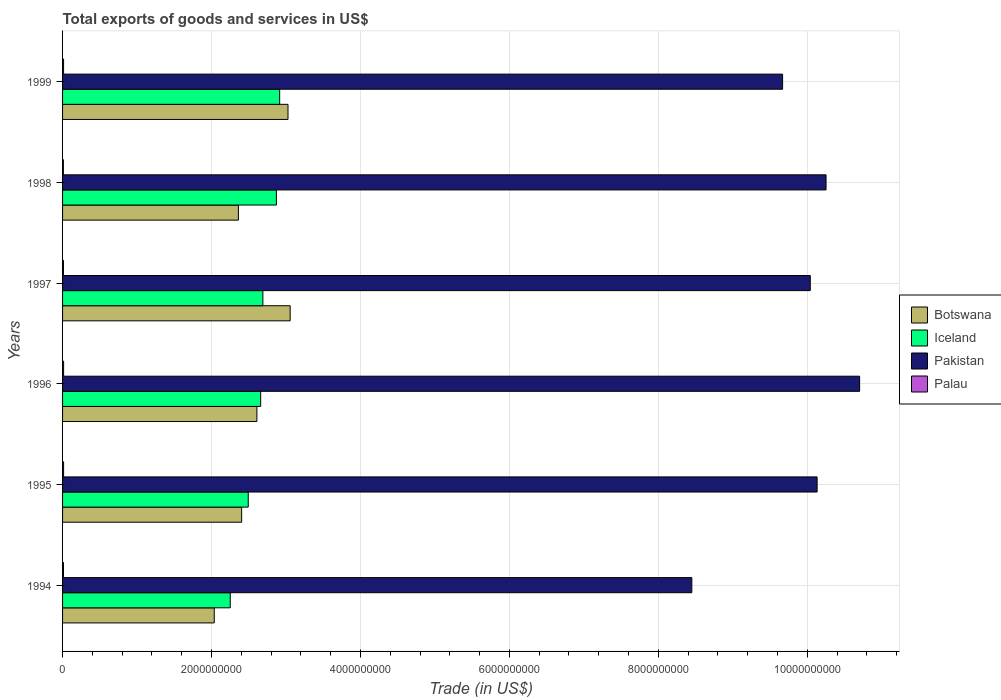Are the number of bars on each tick of the Y-axis equal?
Provide a short and direct response. Yes. In how many cases, is the number of bars for a given year not equal to the number of legend labels?
Keep it short and to the point. 0. What is the total exports of goods and services in Palau in 1997?
Offer a terse response. 1.18e+07. Across all years, what is the maximum total exports of goods and services in Palau?
Provide a succinct answer. 1.39e+07. Across all years, what is the minimum total exports of goods and services in Pakistan?
Keep it short and to the point. 8.45e+09. In which year was the total exports of goods and services in Palau maximum?
Ensure brevity in your answer.  1996. In which year was the total exports of goods and services in Pakistan minimum?
Provide a short and direct response. 1994. What is the total total exports of goods and services in Palau in the graph?
Keep it short and to the point. 7.69e+07. What is the difference between the total exports of goods and services in Iceland in 1998 and that in 1999?
Your answer should be very brief. -4.36e+07. What is the difference between the total exports of goods and services in Iceland in 1997 and the total exports of goods and services in Pakistan in 1998?
Make the answer very short. -7.56e+09. What is the average total exports of goods and services in Palau per year?
Provide a succinct answer. 1.28e+07. In the year 1994, what is the difference between the total exports of goods and services in Palau and total exports of goods and services in Iceland?
Your response must be concise. -2.24e+09. What is the ratio of the total exports of goods and services in Pakistan in 1996 to that in 1997?
Provide a short and direct response. 1.07. Is the total exports of goods and services in Botswana in 1995 less than that in 1998?
Ensure brevity in your answer.  No. Is the difference between the total exports of goods and services in Palau in 1995 and 1999 greater than the difference between the total exports of goods and services in Iceland in 1995 and 1999?
Keep it short and to the point. Yes. What is the difference between the highest and the second highest total exports of goods and services in Botswana?
Make the answer very short. 2.92e+07. What is the difference between the highest and the lowest total exports of goods and services in Botswana?
Your answer should be very brief. 1.02e+09. In how many years, is the total exports of goods and services in Iceland greater than the average total exports of goods and services in Iceland taken over all years?
Offer a very short reply. 4. Is the sum of the total exports of goods and services in Iceland in 1994 and 1996 greater than the maximum total exports of goods and services in Palau across all years?
Your response must be concise. Yes. What does the 1st bar from the top in 1999 represents?
Give a very brief answer. Palau. What does the 2nd bar from the bottom in 1996 represents?
Your response must be concise. Iceland. Is it the case that in every year, the sum of the total exports of goods and services in Palau and total exports of goods and services in Botswana is greater than the total exports of goods and services in Iceland?
Provide a short and direct response. No. Are all the bars in the graph horizontal?
Keep it short and to the point. Yes. How many years are there in the graph?
Your answer should be very brief. 6. What is the difference between two consecutive major ticks on the X-axis?
Provide a short and direct response. 2.00e+09. Are the values on the major ticks of X-axis written in scientific E-notation?
Your answer should be compact. No. Does the graph contain any zero values?
Ensure brevity in your answer.  No. What is the title of the graph?
Your answer should be compact. Total exports of goods and services in US$. What is the label or title of the X-axis?
Ensure brevity in your answer.  Trade (in US$). What is the label or title of the Y-axis?
Provide a short and direct response. Years. What is the Trade (in US$) of Botswana in 1994?
Make the answer very short. 2.04e+09. What is the Trade (in US$) in Iceland in 1994?
Give a very brief answer. 2.25e+09. What is the Trade (in US$) in Pakistan in 1994?
Provide a succinct answer. 8.45e+09. What is the Trade (in US$) in Palau in 1994?
Your response must be concise. 1.26e+07. What is the Trade (in US$) in Botswana in 1995?
Offer a terse response. 2.40e+09. What is the Trade (in US$) in Iceland in 1995?
Your answer should be very brief. 2.49e+09. What is the Trade (in US$) in Pakistan in 1995?
Offer a very short reply. 1.01e+1. What is the Trade (in US$) of Palau in 1995?
Offer a very short reply. 1.39e+07. What is the Trade (in US$) in Botswana in 1996?
Make the answer very short. 2.61e+09. What is the Trade (in US$) in Iceland in 1996?
Give a very brief answer. 2.66e+09. What is the Trade (in US$) of Pakistan in 1996?
Keep it short and to the point. 1.07e+1. What is the Trade (in US$) of Palau in 1996?
Offer a very short reply. 1.39e+07. What is the Trade (in US$) in Botswana in 1997?
Keep it short and to the point. 3.06e+09. What is the Trade (in US$) of Iceland in 1997?
Make the answer very short. 2.69e+09. What is the Trade (in US$) in Pakistan in 1997?
Offer a very short reply. 1.00e+1. What is the Trade (in US$) in Palau in 1997?
Your answer should be very brief. 1.18e+07. What is the Trade (in US$) of Botswana in 1998?
Your answer should be very brief. 2.36e+09. What is the Trade (in US$) of Iceland in 1998?
Offer a very short reply. 2.87e+09. What is the Trade (in US$) of Pakistan in 1998?
Your answer should be compact. 1.03e+1. What is the Trade (in US$) of Palau in 1998?
Provide a short and direct response. 1.11e+07. What is the Trade (in US$) of Botswana in 1999?
Keep it short and to the point. 3.03e+09. What is the Trade (in US$) of Iceland in 1999?
Your response must be concise. 2.92e+09. What is the Trade (in US$) of Pakistan in 1999?
Offer a very short reply. 9.67e+09. What is the Trade (in US$) of Palau in 1999?
Offer a terse response. 1.36e+07. Across all years, what is the maximum Trade (in US$) of Botswana?
Give a very brief answer. 3.06e+09. Across all years, what is the maximum Trade (in US$) in Iceland?
Provide a succinct answer. 2.92e+09. Across all years, what is the maximum Trade (in US$) of Pakistan?
Provide a short and direct response. 1.07e+1. Across all years, what is the maximum Trade (in US$) in Palau?
Offer a terse response. 1.39e+07. Across all years, what is the minimum Trade (in US$) in Botswana?
Offer a very short reply. 2.04e+09. Across all years, what is the minimum Trade (in US$) in Iceland?
Offer a very short reply. 2.25e+09. Across all years, what is the minimum Trade (in US$) of Pakistan?
Your answer should be compact. 8.45e+09. Across all years, what is the minimum Trade (in US$) in Palau?
Your answer should be compact. 1.11e+07. What is the total Trade (in US$) of Botswana in the graph?
Ensure brevity in your answer.  1.55e+1. What is the total Trade (in US$) in Iceland in the graph?
Ensure brevity in your answer.  1.59e+1. What is the total Trade (in US$) of Pakistan in the graph?
Your answer should be very brief. 5.92e+1. What is the total Trade (in US$) of Palau in the graph?
Provide a succinct answer. 7.69e+07. What is the difference between the Trade (in US$) in Botswana in 1994 and that in 1995?
Provide a short and direct response. -3.68e+08. What is the difference between the Trade (in US$) of Iceland in 1994 and that in 1995?
Offer a terse response. -2.42e+08. What is the difference between the Trade (in US$) of Pakistan in 1994 and that in 1995?
Your response must be concise. -1.68e+09. What is the difference between the Trade (in US$) in Palau in 1994 and that in 1995?
Provide a short and direct response. -1.27e+06. What is the difference between the Trade (in US$) in Botswana in 1994 and that in 1996?
Provide a succinct answer. -5.73e+08. What is the difference between the Trade (in US$) in Iceland in 1994 and that in 1996?
Ensure brevity in your answer.  -4.08e+08. What is the difference between the Trade (in US$) of Pakistan in 1994 and that in 1996?
Your answer should be compact. -2.25e+09. What is the difference between the Trade (in US$) of Palau in 1994 and that in 1996?
Keep it short and to the point. -1.31e+06. What is the difference between the Trade (in US$) of Botswana in 1994 and that in 1997?
Provide a short and direct response. -1.02e+09. What is the difference between the Trade (in US$) of Iceland in 1994 and that in 1997?
Ensure brevity in your answer.  -4.38e+08. What is the difference between the Trade (in US$) of Pakistan in 1994 and that in 1997?
Offer a very short reply. -1.59e+09. What is the difference between the Trade (in US$) of Palau in 1994 and that in 1997?
Your response must be concise. 7.88e+05. What is the difference between the Trade (in US$) in Botswana in 1994 and that in 1998?
Your answer should be compact. -3.24e+08. What is the difference between the Trade (in US$) of Iceland in 1994 and that in 1998?
Your answer should be very brief. -6.20e+08. What is the difference between the Trade (in US$) in Pakistan in 1994 and that in 1998?
Provide a succinct answer. -1.80e+09. What is the difference between the Trade (in US$) in Palau in 1994 and that in 1998?
Your answer should be very brief. 1.51e+06. What is the difference between the Trade (in US$) of Botswana in 1994 and that in 1999?
Your answer should be very brief. -9.90e+08. What is the difference between the Trade (in US$) in Iceland in 1994 and that in 1999?
Your response must be concise. -6.64e+08. What is the difference between the Trade (in US$) in Pakistan in 1994 and that in 1999?
Provide a succinct answer. -1.22e+09. What is the difference between the Trade (in US$) of Palau in 1994 and that in 1999?
Keep it short and to the point. -9.74e+05. What is the difference between the Trade (in US$) of Botswana in 1995 and that in 1996?
Provide a succinct answer. -2.05e+08. What is the difference between the Trade (in US$) in Iceland in 1995 and that in 1996?
Your response must be concise. -1.67e+08. What is the difference between the Trade (in US$) of Pakistan in 1995 and that in 1996?
Offer a very short reply. -5.71e+08. What is the difference between the Trade (in US$) in Palau in 1995 and that in 1996?
Your answer should be very brief. -3.90e+04. What is the difference between the Trade (in US$) in Botswana in 1995 and that in 1997?
Provide a short and direct response. -6.51e+08. What is the difference between the Trade (in US$) of Iceland in 1995 and that in 1997?
Ensure brevity in your answer.  -1.96e+08. What is the difference between the Trade (in US$) in Pakistan in 1995 and that in 1997?
Your response must be concise. 9.18e+07. What is the difference between the Trade (in US$) of Palau in 1995 and that in 1997?
Provide a succinct answer. 2.06e+06. What is the difference between the Trade (in US$) of Botswana in 1995 and that in 1998?
Offer a very short reply. 4.37e+07. What is the difference between the Trade (in US$) in Iceland in 1995 and that in 1998?
Provide a short and direct response. -3.78e+08. What is the difference between the Trade (in US$) of Pakistan in 1995 and that in 1998?
Provide a succinct answer. -1.20e+08. What is the difference between the Trade (in US$) of Palau in 1995 and that in 1998?
Make the answer very short. 2.77e+06. What is the difference between the Trade (in US$) in Botswana in 1995 and that in 1999?
Provide a succinct answer. -6.22e+08. What is the difference between the Trade (in US$) in Iceland in 1995 and that in 1999?
Give a very brief answer. -4.22e+08. What is the difference between the Trade (in US$) of Pakistan in 1995 and that in 1999?
Give a very brief answer. 4.64e+08. What is the difference between the Trade (in US$) in Palau in 1995 and that in 1999?
Your answer should be very brief. 2.94e+05. What is the difference between the Trade (in US$) in Botswana in 1996 and that in 1997?
Offer a very short reply. -4.47e+08. What is the difference between the Trade (in US$) in Iceland in 1996 and that in 1997?
Offer a terse response. -2.97e+07. What is the difference between the Trade (in US$) in Pakistan in 1996 and that in 1997?
Offer a terse response. 6.63e+08. What is the difference between the Trade (in US$) in Palau in 1996 and that in 1997?
Make the answer very short. 2.10e+06. What is the difference between the Trade (in US$) of Botswana in 1996 and that in 1998?
Your response must be concise. 2.48e+08. What is the difference between the Trade (in US$) in Iceland in 1996 and that in 1998?
Offer a terse response. -2.11e+08. What is the difference between the Trade (in US$) in Pakistan in 1996 and that in 1998?
Offer a terse response. 4.51e+08. What is the difference between the Trade (in US$) of Palau in 1996 and that in 1998?
Ensure brevity in your answer.  2.81e+06. What is the difference between the Trade (in US$) of Botswana in 1996 and that in 1999?
Ensure brevity in your answer.  -4.18e+08. What is the difference between the Trade (in US$) of Iceland in 1996 and that in 1999?
Your response must be concise. -2.55e+08. What is the difference between the Trade (in US$) in Pakistan in 1996 and that in 1999?
Give a very brief answer. 1.03e+09. What is the difference between the Trade (in US$) in Palau in 1996 and that in 1999?
Provide a short and direct response. 3.33e+05. What is the difference between the Trade (in US$) of Botswana in 1997 and that in 1998?
Offer a very short reply. 6.95e+08. What is the difference between the Trade (in US$) of Iceland in 1997 and that in 1998?
Make the answer very short. -1.82e+08. What is the difference between the Trade (in US$) in Pakistan in 1997 and that in 1998?
Give a very brief answer. -2.12e+08. What is the difference between the Trade (in US$) in Palau in 1997 and that in 1998?
Provide a succinct answer. 7.18e+05. What is the difference between the Trade (in US$) in Botswana in 1997 and that in 1999?
Make the answer very short. 2.92e+07. What is the difference between the Trade (in US$) of Iceland in 1997 and that in 1999?
Offer a very short reply. -2.25e+08. What is the difference between the Trade (in US$) in Pakistan in 1997 and that in 1999?
Your answer should be compact. 3.72e+08. What is the difference between the Trade (in US$) in Palau in 1997 and that in 1999?
Provide a succinct answer. -1.76e+06. What is the difference between the Trade (in US$) in Botswana in 1998 and that in 1999?
Make the answer very short. -6.66e+08. What is the difference between the Trade (in US$) of Iceland in 1998 and that in 1999?
Your answer should be compact. -4.36e+07. What is the difference between the Trade (in US$) in Pakistan in 1998 and that in 1999?
Make the answer very short. 5.84e+08. What is the difference between the Trade (in US$) of Palau in 1998 and that in 1999?
Offer a very short reply. -2.48e+06. What is the difference between the Trade (in US$) of Botswana in 1994 and the Trade (in US$) of Iceland in 1995?
Offer a terse response. -4.57e+08. What is the difference between the Trade (in US$) in Botswana in 1994 and the Trade (in US$) in Pakistan in 1995?
Offer a terse response. -8.10e+09. What is the difference between the Trade (in US$) of Botswana in 1994 and the Trade (in US$) of Palau in 1995?
Make the answer very short. 2.02e+09. What is the difference between the Trade (in US$) in Iceland in 1994 and the Trade (in US$) in Pakistan in 1995?
Keep it short and to the point. -7.88e+09. What is the difference between the Trade (in US$) in Iceland in 1994 and the Trade (in US$) in Palau in 1995?
Offer a terse response. 2.24e+09. What is the difference between the Trade (in US$) of Pakistan in 1994 and the Trade (in US$) of Palau in 1995?
Ensure brevity in your answer.  8.44e+09. What is the difference between the Trade (in US$) of Botswana in 1994 and the Trade (in US$) of Iceland in 1996?
Offer a terse response. -6.23e+08. What is the difference between the Trade (in US$) of Botswana in 1994 and the Trade (in US$) of Pakistan in 1996?
Give a very brief answer. -8.67e+09. What is the difference between the Trade (in US$) of Botswana in 1994 and the Trade (in US$) of Palau in 1996?
Provide a succinct answer. 2.02e+09. What is the difference between the Trade (in US$) of Iceland in 1994 and the Trade (in US$) of Pakistan in 1996?
Provide a succinct answer. -8.45e+09. What is the difference between the Trade (in US$) of Iceland in 1994 and the Trade (in US$) of Palau in 1996?
Provide a succinct answer. 2.24e+09. What is the difference between the Trade (in US$) of Pakistan in 1994 and the Trade (in US$) of Palau in 1996?
Ensure brevity in your answer.  8.44e+09. What is the difference between the Trade (in US$) of Botswana in 1994 and the Trade (in US$) of Iceland in 1997?
Provide a succinct answer. -6.53e+08. What is the difference between the Trade (in US$) of Botswana in 1994 and the Trade (in US$) of Pakistan in 1997?
Your answer should be very brief. -8.00e+09. What is the difference between the Trade (in US$) of Botswana in 1994 and the Trade (in US$) of Palau in 1997?
Your answer should be compact. 2.03e+09. What is the difference between the Trade (in US$) in Iceland in 1994 and the Trade (in US$) in Pakistan in 1997?
Your answer should be compact. -7.79e+09. What is the difference between the Trade (in US$) in Iceland in 1994 and the Trade (in US$) in Palau in 1997?
Keep it short and to the point. 2.24e+09. What is the difference between the Trade (in US$) in Pakistan in 1994 and the Trade (in US$) in Palau in 1997?
Offer a very short reply. 8.44e+09. What is the difference between the Trade (in US$) in Botswana in 1994 and the Trade (in US$) in Iceland in 1998?
Your answer should be compact. -8.35e+08. What is the difference between the Trade (in US$) of Botswana in 1994 and the Trade (in US$) of Pakistan in 1998?
Offer a very short reply. -8.22e+09. What is the difference between the Trade (in US$) of Botswana in 1994 and the Trade (in US$) of Palau in 1998?
Your answer should be very brief. 2.03e+09. What is the difference between the Trade (in US$) in Iceland in 1994 and the Trade (in US$) in Pakistan in 1998?
Give a very brief answer. -8.00e+09. What is the difference between the Trade (in US$) of Iceland in 1994 and the Trade (in US$) of Palau in 1998?
Your answer should be compact. 2.24e+09. What is the difference between the Trade (in US$) in Pakistan in 1994 and the Trade (in US$) in Palau in 1998?
Keep it short and to the point. 8.44e+09. What is the difference between the Trade (in US$) in Botswana in 1994 and the Trade (in US$) in Iceland in 1999?
Your answer should be compact. -8.78e+08. What is the difference between the Trade (in US$) in Botswana in 1994 and the Trade (in US$) in Pakistan in 1999?
Keep it short and to the point. -7.63e+09. What is the difference between the Trade (in US$) of Botswana in 1994 and the Trade (in US$) of Palau in 1999?
Your response must be concise. 2.02e+09. What is the difference between the Trade (in US$) in Iceland in 1994 and the Trade (in US$) in Pakistan in 1999?
Offer a terse response. -7.42e+09. What is the difference between the Trade (in US$) of Iceland in 1994 and the Trade (in US$) of Palau in 1999?
Provide a succinct answer. 2.24e+09. What is the difference between the Trade (in US$) in Pakistan in 1994 and the Trade (in US$) in Palau in 1999?
Your answer should be compact. 8.44e+09. What is the difference between the Trade (in US$) in Botswana in 1995 and the Trade (in US$) in Iceland in 1996?
Keep it short and to the point. -2.55e+08. What is the difference between the Trade (in US$) of Botswana in 1995 and the Trade (in US$) of Pakistan in 1996?
Offer a very short reply. -8.30e+09. What is the difference between the Trade (in US$) in Botswana in 1995 and the Trade (in US$) in Palau in 1996?
Provide a succinct answer. 2.39e+09. What is the difference between the Trade (in US$) in Iceland in 1995 and the Trade (in US$) in Pakistan in 1996?
Provide a short and direct response. -8.21e+09. What is the difference between the Trade (in US$) in Iceland in 1995 and the Trade (in US$) in Palau in 1996?
Ensure brevity in your answer.  2.48e+09. What is the difference between the Trade (in US$) in Pakistan in 1995 and the Trade (in US$) in Palau in 1996?
Offer a terse response. 1.01e+1. What is the difference between the Trade (in US$) of Botswana in 1995 and the Trade (in US$) of Iceland in 1997?
Give a very brief answer. -2.85e+08. What is the difference between the Trade (in US$) in Botswana in 1995 and the Trade (in US$) in Pakistan in 1997?
Your answer should be very brief. -7.64e+09. What is the difference between the Trade (in US$) in Botswana in 1995 and the Trade (in US$) in Palau in 1997?
Provide a short and direct response. 2.39e+09. What is the difference between the Trade (in US$) of Iceland in 1995 and the Trade (in US$) of Pakistan in 1997?
Ensure brevity in your answer.  -7.55e+09. What is the difference between the Trade (in US$) of Iceland in 1995 and the Trade (in US$) of Palau in 1997?
Ensure brevity in your answer.  2.48e+09. What is the difference between the Trade (in US$) of Pakistan in 1995 and the Trade (in US$) of Palau in 1997?
Give a very brief answer. 1.01e+1. What is the difference between the Trade (in US$) in Botswana in 1995 and the Trade (in US$) in Iceland in 1998?
Give a very brief answer. -4.67e+08. What is the difference between the Trade (in US$) in Botswana in 1995 and the Trade (in US$) in Pakistan in 1998?
Your answer should be compact. -7.85e+09. What is the difference between the Trade (in US$) of Botswana in 1995 and the Trade (in US$) of Palau in 1998?
Make the answer very short. 2.39e+09. What is the difference between the Trade (in US$) of Iceland in 1995 and the Trade (in US$) of Pakistan in 1998?
Ensure brevity in your answer.  -7.76e+09. What is the difference between the Trade (in US$) in Iceland in 1995 and the Trade (in US$) in Palau in 1998?
Offer a very short reply. 2.48e+09. What is the difference between the Trade (in US$) of Pakistan in 1995 and the Trade (in US$) of Palau in 1998?
Offer a very short reply. 1.01e+1. What is the difference between the Trade (in US$) in Botswana in 1995 and the Trade (in US$) in Iceland in 1999?
Keep it short and to the point. -5.10e+08. What is the difference between the Trade (in US$) of Botswana in 1995 and the Trade (in US$) of Pakistan in 1999?
Your response must be concise. -7.26e+09. What is the difference between the Trade (in US$) in Botswana in 1995 and the Trade (in US$) in Palau in 1999?
Your answer should be compact. 2.39e+09. What is the difference between the Trade (in US$) of Iceland in 1995 and the Trade (in US$) of Pakistan in 1999?
Make the answer very short. -7.18e+09. What is the difference between the Trade (in US$) of Iceland in 1995 and the Trade (in US$) of Palau in 1999?
Make the answer very short. 2.48e+09. What is the difference between the Trade (in US$) of Pakistan in 1995 and the Trade (in US$) of Palau in 1999?
Offer a very short reply. 1.01e+1. What is the difference between the Trade (in US$) in Botswana in 1996 and the Trade (in US$) in Iceland in 1997?
Provide a short and direct response. -8.04e+07. What is the difference between the Trade (in US$) in Botswana in 1996 and the Trade (in US$) in Pakistan in 1997?
Keep it short and to the point. -7.43e+09. What is the difference between the Trade (in US$) in Botswana in 1996 and the Trade (in US$) in Palau in 1997?
Provide a short and direct response. 2.60e+09. What is the difference between the Trade (in US$) of Iceland in 1996 and the Trade (in US$) of Pakistan in 1997?
Ensure brevity in your answer.  -7.38e+09. What is the difference between the Trade (in US$) of Iceland in 1996 and the Trade (in US$) of Palau in 1997?
Offer a very short reply. 2.65e+09. What is the difference between the Trade (in US$) in Pakistan in 1996 and the Trade (in US$) in Palau in 1997?
Provide a succinct answer. 1.07e+1. What is the difference between the Trade (in US$) in Botswana in 1996 and the Trade (in US$) in Iceland in 1998?
Your answer should be very brief. -2.62e+08. What is the difference between the Trade (in US$) of Botswana in 1996 and the Trade (in US$) of Pakistan in 1998?
Your answer should be compact. -7.64e+09. What is the difference between the Trade (in US$) in Botswana in 1996 and the Trade (in US$) in Palau in 1998?
Offer a very short reply. 2.60e+09. What is the difference between the Trade (in US$) of Iceland in 1996 and the Trade (in US$) of Pakistan in 1998?
Your answer should be compact. -7.59e+09. What is the difference between the Trade (in US$) in Iceland in 1996 and the Trade (in US$) in Palau in 1998?
Keep it short and to the point. 2.65e+09. What is the difference between the Trade (in US$) in Pakistan in 1996 and the Trade (in US$) in Palau in 1998?
Make the answer very short. 1.07e+1. What is the difference between the Trade (in US$) of Botswana in 1996 and the Trade (in US$) of Iceland in 1999?
Keep it short and to the point. -3.06e+08. What is the difference between the Trade (in US$) of Botswana in 1996 and the Trade (in US$) of Pakistan in 1999?
Offer a terse response. -7.06e+09. What is the difference between the Trade (in US$) in Botswana in 1996 and the Trade (in US$) in Palau in 1999?
Ensure brevity in your answer.  2.60e+09. What is the difference between the Trade (in US$) in Iceland in 1996 and the Trade (in US$) in Pakistan in 1999?
Your answer should be very brief. -7.01e+09. What is the difference between the Trade (in US$) in Iceland in 1996 and the Trade (in US$) in Palau in 1999?
Make the answer very short. 2.65e+09. What is the difference between the Trade (in US$) in Pakistan in 1996 and the Trade (in US$) in Palau in 1999?
Offer a terse response. 1.07e+1. What is the difference between the Trade (in US$) of Botswana in 1997 and the Trade (in US$) of Iceland in 1998?
Provide a succinct answer. 1.85e+08. What is the difference between the Trade (in US$) of Botswana in 1997 and the Trade (in US$) of Pakistan in 1998?
Provide a succinct answer. -7.20e+09. What is the difference between the Trade (in US$) in Botswana in 1997 and the Trade (in US$) in Palau in 1998?
Provide a succinct answer. 3.05e+09. What is the difference between the Trade (in US$) in Iceland in 1997 and the Trade (in US$) in Pakistan in 1998?
Your answer should be compact. -7.56e+09. What is the difference between the Trade (in US$) of Iceland in 1997 and the Trade (in US$) of Palau in 1998?
Keep it short and to the point. 2.68e+09. What is the difference between the Trade (in US$) of Pakistan in 1997 and the Trade (in US$) of Palau in 1998?
Make the answer very short. 1.00e+1. What is the difference between the Trade (in US$) in Botswana in 1997 and the Trade (in US$) in Iceland in 1999?
Give a very brief answer. 1.41e+08. What is the difference between the Trade (in US$) of Botswana in 1997 and the Trade (in US$) of Pakistan in 1999?
Make the answer very short. -6.61e+09. What is the difference between the Trade (in US$) of Botswana in 1997 and the Trade (in US$) of Palau in 1999?
Your answer should be compact. 3.04e+09. What is the difference between the Trade (in US$) of Iceland in 1997 and the Trade (in US$) of Pakistan in 1999?
Your answer should be compact. -6.98e+09. What is the difference between the Trade (in US$) in Iceland in 1997 and the Trade (in US$) in Palau in 1999?
Your answer should be very brief. 2.68e+09. What is the difference between the Trade (in US$) in Pakistan in 1997 and the Trade (in US$) in Palau in 1999?
Your response must be concise. 1.00e+1. What is the difference between the Trade (in US$) of Botswana in 1998 and the Trade (in US$) of Iceland in 1999?
Keep it short and to the point. -5.54e+08. What is the difference between the Trade (in US$) in Botswana in 1998 and the Trade (in US$) in Pakistan in 1999?
Your response must be concise. -7.31e+09. What is the difference between the Trade (in US$) in Botswana in 1998 and the Trade (in US$) in Palau in 1999?
Keep it short and to the point. 2.35e+09. What is the difference between the Trade (in US$) of Iceland in 1998 and the Trade (in US$) of Pakistan in 1999?
Keep it short and to the point. -6.80e+09. What is the difference between the Trade (in US$) of Iceland in 1998 and the Trade (in US$) of Palau in 1999?
Provide a short and direct response. 2.86e+09. What is the difference between the Trade (in US$) in Pakistan in 1998 and the Trade (in US$) in Palau in 1999?
Your response must be concise. 1.02e+1. What is the average Trade (in US$) of Botswana per year?
Offer a terse response. 2.58e+09. What is the average Trade (in US$) of Iceland per year?
Your answer should be compact. 2.65e+09. What is the average Trade (in US$) in Pakistan per year?
Your answer should be compact. 9.87e+09. What is the average Trade (in US$) in Palau per year?
Make the answer very short. 1.28e+07. In the year 1994, what is the difference between the Trade (in US$) in Botswana and Trade (in US$) in Iceland?
Your answer should be very brief. -2.15e+08. In the year 1994, what is the difference between the Trade (in US$) in Botswana and Trade (in US$) in Pakistan?
Offer a terse response. -6.41e+09. In the year 1994, what is the difference between the Trade (in US$) in Botswana and Trade (in US$) in Palau?
Ensure brevity in your answer.  2.02e+09. In the year 1994, what is the difference between the Trade (in US$) of Iceland and Trade (in US$) of Pakistan?
Give a very brief answer. -6.20e+09. In the year 1994, what is the difference between the Trade (in US$) in Iceland and Trade (in US$) in Palau?
Provide a short and direct response. 2.24e+09. In the year 1994, what is the difference between the Trade (in US$) in Pakistan and Trade (in US$) in Palau?
Offer a terse response. 8.44e+09. In the year 1995, what is the difference between the Trade (in US$) of Botswana and Trade (in US$) of Iceland?
Ensure brevity in your answer.  -8.86e+07. In the year 1995, what is the difference between the Trade (in US$) of Botswana and Trade (in US$) of Pakistan?
Make the answer very short. -7.73e+09. In the year 1995, what is the difference between the Trade (in US$) in Botswana and Trade (in US$) in Palau?
Ensure brevity in your answer.  2.39e+09. In the year 1995, what is the difference between the Trade (in US$) of Iceland and Trade (in US$) of Pakistan?
Your response must be concise. -7.64e+09. In the year 1995, what is the difference between the Trade (in US$) of Iceland and Trade (in US$) of Palau?
Your answer should be compact. 2.48e+09. In the year 1995, what is the difference between the Trade (in US$) in Pakistan and Trade (in US$) in Palau?
Ensure brevity in your answer.  1.01e+1. In the year 1996, what is the difference between the Trade (in US$) of Botswana and Trade (in US$) of Iceland?
Your response must be concise. -5.06e+07. In the year 1996, what is the difference between the Trade (in US$) in Botswana and Trade (in US$) in Pakistan?
Your response must be concise. -8.09e+09. In the year 1996, what is the difference between the Trade (in US$) in Botswana and Trade (in US$) in Palau?
Give a very brief answer. 2.60e+09. In the year 1996, what is the difference between the Trade (in US$) of Iceland and Trade (in US$) of Pakistan?
Provide a succinct answer. -8.04e+09. In the year 1996, what is the difference between the Trade (in US$) of Iceland and Trade (in US$) of Palau?
Your answer should be very brief. 2.65e+09. In the year 1996, what is the difference between the Trade (in US$) of Pakistan and Trade (in US$) of Palau?
Make the answer very short. 1.07e+1. In the year 1997, what is the difference between the Trade (in US$) of Botswana and Trade (in US$) of Iceland?
Provide a succinct answer. 3.67e+08. In the year 1997, what is the difference between the Trade (in US$) of Botswana and Trade (in US$) of Pakistan?
Your response must be concise. -6.98e+09. In the year 1997, what is the difference between the Trade (in US$) of Botswana and Trade (in US$) of Palau?
Give a very brief answer. 3.04e+09. In the year 1997, what is the difference between the Trade (in US$) in Iceland and Trade (in US$) in Pakistan?
Make the answer very short. -7.35e+09. In the year 1997, what is the difference between the Trade (in US$) in Iceland and Trade (in US$) in Palau?
Provide a short and direct response. 2.68e+09. In the year 1997, what is the difference between the Trade (in US$) in Pakistan and Trade (in US$) in Palau?
Provide a succinct answer. 1.00e+1. In the year 1998, what is the difference between the Trade (in US$) in Botswana and Trade (in US$) in Iceland?
Offer a terse response. -5.10e+08. In the year 1998, what is the difference between the Trade (in US$) in Botswana and Trade (in US$) in Pakistan?
Provide a short and direct response. -7.89e+09. In the year 1998, what is the difference between the Trade (in US$) of Botswana and Trade (in US$) of Palau?
Provide a succinct answer. 2.35e+09. In the year 1998, what is the difference between the Trade (in US$) in Iceland and Trade (in US$) in Pakistan?
Provide a short and direct response. -7.38e+09. In the year 1998, what is the difference between the Trade (in US$) of Iceland and Trade (in US$) of Palau?
Keep it short and to the point. 2.86e+09. In the year 1998, what is the difference between the Trade (in US$) of Pakistan and Trade (in US$) of Palau?
Your answer should be compact. 1.02e+1. In the year 1999, what is the difference between the Trade (in US$) in Botswana and Trade (in US$) in Iceland?
Your answer should be very brief. 1.12e+08. In the year 1999, what is the difference between the Trade (in US$) of Botswana and Trade (in US$) of Pakistan?
Give a very brief answer. -6.64e+09. In the year 1999, what is the difference between the Trade (in US$) in Botswana and Trade (in US$) in Palau?
Ensure brevity in your answer.  3.01e+09. In the year 1999, what is the difference between the Trade (in US$) of Iceland and Trade (in US$) of Pakistan?
Provide a short and direct response. -6.75e+09. In the year 1999, what is the difference between the Trade (in US$) in Iceland and Trade (in US$) in Palau?
Your response must be concise. 2.90e+09. In the year 1999, what is the difference between the Trade (in US$) in Pakistan and Trade (in US$) in Palau?
Make the answer very short. 9.66e+09. What is the ratio of the Trade (in US$) of Botswana in 1994 to that in 1995?
Your answer should be compact. 0.85. What is the ratio of the Trade (in US$) in Iceland in 1994 to that in 1995?
Give a very brief answer. 0.9. What is the ratio of the Trade (in US$) in Pakistan in 1994 to that in 1995?
Provide a short and direct response. 0.83. What is the ratio of the Trade (in US$) of Palau in 1994 to that in 1995?
Give a very brief answer. 0.91. What is the ratio of the Trade (in US$) in Botswana in 1994 to that in 1996?
Your answer should be very brief. 0.78. What is the ratio of the Trade (in US$) in Iceland in 1994 to that in 1996?
Your answer should be compact. 0.85. What is the ratio of the Trade (in US$) of Pakistan in 1994 to that in 1996?
Keep it short and to the point. 0.79. What is the ratio of the Trade (in US$) of Palau in 1994 to that in 1996?
Provide a succinct answer. 0.91. What is the ratio of the Trade (in US$) of Botswana in 1994 to that in 1997?
Keep it short and to the point. 0.67. What is the ratio of the Trade (in US$) in Iceland in 1994 to that in 1997?
Offer a very short reply. 0.84. What is the ratio of the Trade (in US$) of Pakistan in 1994 to that in 1997?
Your answer should be compact. 0.84. What is the ratio of the Trade (in US$) of Palau in 1994 to that in 1997?
Your answer should be very brief. 1.07. What is the ratio of the Trade (in US$) in Botswana in 1994 to that in 1998?
Provide a short and direct response. 0.86. What is the ratio of the Trade (in US$) in Iceland in 1994 to that in 1998?
Your answer should be compact. 0.78. What is the ratio of the Trade (in US$) in Pakistan in 1994 to that in 1998?
Your answer should be compact. 0.82. What is the ratio of the Trade (in US$) of Palau in 1994 to that in 1998?
Offer a terse response. 1.14. What is the ratio of the Trade (in US$) in Botswana in 1994 to that in 1999?
Provide a succinct answer. 0.67. What is the ratio of the Trade (in US$) of Iceland in 1994 to that in 1999?
Your answer should be very brief. 0.77. What is the ratio of the Trade (in US$) of Pakistan in 1994 to that in 1999?
Your response must be concise. 0.87. What is the ratio of the Trade (in US$) in Palau in 1994 to that in 1999?
Offer a very short reply. 0.93. What is the ratio of the Trade (in US$) of Botswana in 1995 to that in 1996?
Make the answer very short. 0.92. What is the ratio of the Trade (in US$) in Iceland in 1995 to that in 1996?
Provide a succinct answer. 0.94. What is the ratio of the Trade (in US$) of Pakistan in 1995 to that in 1996?
Provide a succinct answer. 0.95. What is the ratio of the Trade (in US$) in Botswana in 1995 to that in 1997?
Your answer should be very brief. 0.79. What is the ratio of the Trade (in US$) of Iceland in 1995 to that in 1997?
Provide a short and direct response. 0.93. What is the ratio of the Trade (in US$) of Pakistan in 1995 to that in 1997?
Make the answer very short. 1.01. What is the ratio of the Trade (in US$) of Palau in 1995 to that in 1997?
Offer a very short reply. 1.17. What is the ratio of the Trade (in US$) of Botswana in 1995 to that in 1998?
Offer a very short reply. 1.02. What is the ratio of the Trade (in US$) of Iceland in 1995 to that in 1998?
Your answer should be very brief. 0.87. What is the ratio of the Trade (in US$) of Pakistan in 1995 to that in 1998?
Make the answer very short. 0.99. What is the ratio of the Trade (in US$) of Botswana in 1995 to that in 1999?
Make the answer very short. 0.79. What is the ratio of the Trade (in US$) in Iceland in 1995 to that in 1999?
Keep it short and to the point. 0.86. What is the ratio of the Trade (in US$) of Pakistan in 1995 to that in 1999?
Make the answer very short. 1.05. What is the ratio of the Trade (in US$) of Palau in 1995 to that in 1999?
Offer a very short reply. 1.02. What is the ratio of the Trade (in US$) of Botswana in 1996 to that in 1997?
Offer a very short reply. 0.85. What is the ratio of the Trade (in US$) of Pakistan in 1996 to that in 1997?
Your answer should be very brief. 1.07. What is the ratio of the Trade (in US$) in Palau in 1996 to that in 1997?
Provide a succinct answer. 1.18. What is the ratio of the Trade (in US$) in Botswana in 1996 to that in 1998?
Offer a terse response. 1.11. What is the ratio of the Trade (in US$) of Iceland in 1996 to that in 1998?
Provide a succinct answer. 0.93. What is the ratio of the Trade (in US$) in Pakistan in 1996 to that in 1998?
Offer a terse response. 1.04. What is the ratio of the Trade (in US$) in Palau in 1996 to that in 1998?
Make the answer very short. 1.25. What is the ratio of the Trade (in US$) in Botswana in 1996 to that in 1999?
Make the answer very short. 0.86. What is the ratio of the Trade (in US$) of Iceland in 1996 to that in 1999?
Your answer should be compact. 0.91. What is the ratio of the Trade (in US$) of Pakistan in 1996 to that in 1999?
Make the answer very short. 1.11. What is the ratio of the Trade (in US$) in Palau in 1996 to that in 1999?
Offer a very short reply. 1.02. What is the ratio of the Trade (in US$) of Botswana in 1997 to that in 1998?
Keep it short and to the point. 1.29. What is the ratio of the Trade (in US$) of Iceland in 1997 to that in 1998?
Your response must be concise. 0.94. What is the ratio of the Trade (in US$) of Pakistan in 1997 to that in 1998?
Keep it short and to the point. 0.98. What is the ratio of the Trade (in US$) of Palau in 1997 to that in 1998?
Provide a short and direct response. 1.06. What is the ratio of the Trade (in US$) in Botswana in 1997 to that in 1999?
Provide a succinct answer. 1.01. What is the ratio of the Trade (in US$) in Iceland in 1997 to that in 1999?
Offer a very short reply. 0.92. What is the ratio of the Trade (in US$) in Pakistan in 1997 to that in 1999?
Ensure brevity in your answer.  1.04. What is the ratio of the Trade (in US$) of Palau in 1997 to that in 1999?
Provide a short and direct response. 0.87. What is the ratio of the Trade (in US$) in Botswana in 1998 to that in 1999?
Provide a short and direct response. 0.78. What is the ratio of the Trade (in US$) of Iceland in 1998 to that in 1999?
Your answer should be very brief. 0.98. What is the ratio of the Trade (in US$) of Pakistan in 1998 to that in 1999?
Keep it short and to the point. 1.06. What is the ratio of the Trade (in US$) in Palau in 1998 to that in 1999?
Your answer should be very brief. 0.82. What is the difference between the highest and the second highest Trade (in US$) in Botswana?
Provide a short and direct response. 2.92e+07. What is the difference between the highest and the second highest Trade (in US$) in Iceland?
Your answer should be very brief. 4.36e+07. What is the difference between the highest and the second highest Trade (in US$) of Pakistan?
Your response must be concise. 4.51e+08. What is the difference between the highest and the second highest Trade (in US$) of Palau?
Provide a short and direct response. 3.90e+04. What is the difference between the highest and the lowest Trade (in US$) in Botswana?
Offer a very short reply. 1.02e+09. What is the difference between the highest and the lowest Trade (in US$) of Iceland?
Provide a succinct answer. 6.64e+08. What is the difference between the highest and the lowest Trade (in US$) in Pakistan?
Offer a very short reply. 2.25e+09. What is the difference between the highest and the lowest Trade (in US$) in Palau?
Keep it short and to the point. 2.81e+06. 